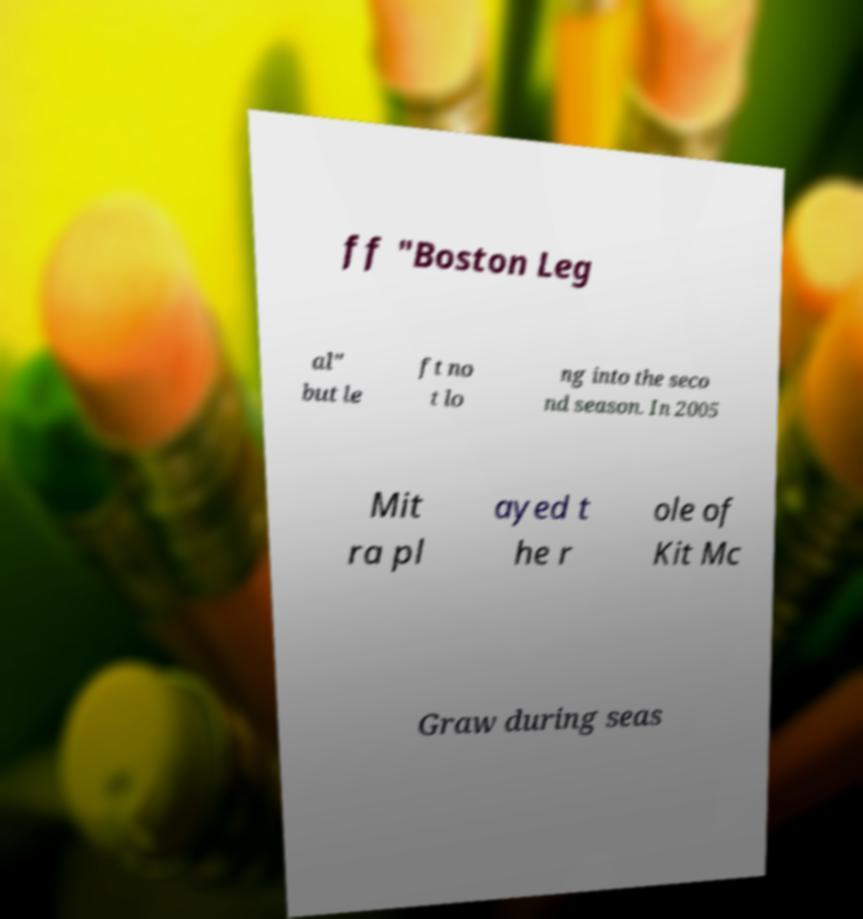Please read and relay the text visible in this image. What does it say? ff "Boston Leg al" but le ft no t lo ng into the seco nd season. In 2005 Mit ra pl ayed t he r ole of Kit Mc Graw during seas 